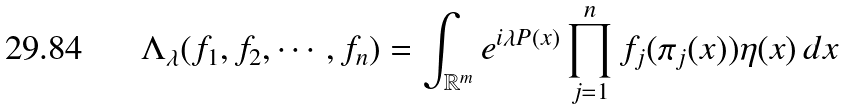<formula> <loc_0><loc_0><loc_500><loc_500>\Lambda _ { \lambda } ( f _ { 1 } , f _ { 2 } , \cdots , f _ { n } ) = \int _ { \mathbb { R } ^ { m } } e ^ { i \lambda P ( x ) } \prod _ { j = 1 } ^ { n } f _ { j } ( \pi _ { j } ( x ) ) \eta ( x ) \, d x</formula> 